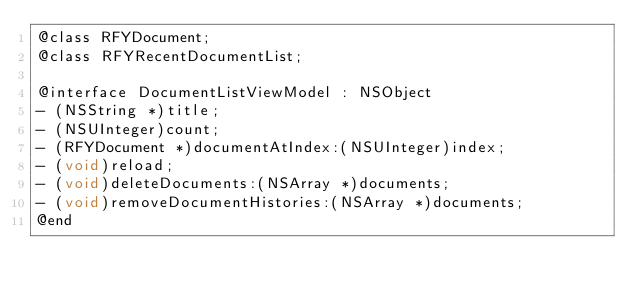Convert code to text. <code><loc_0><loc_0><loc_500><loc_500><_C_>@class RFYDocument;
@class RFYRecentDocumentList;

@interface DocumentListViewModel : NSObject
- (NSString *)title;
- (NSUInteger)count;
- (RFYDocument *)documentAtIndex:(NSUInteger)index;
- (void)reload;
- (void)deleteDocuments:(NSArray *)documents;
- (void)removeDocumentHistories:(NSArray *)documents;
@end
</code> 